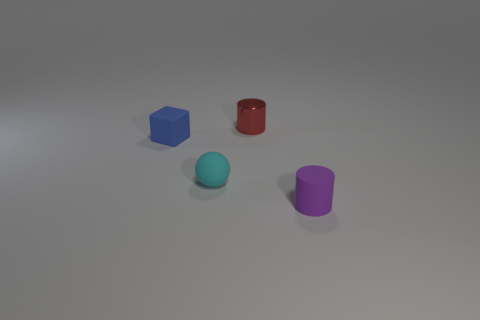Is there a pattern to the arrangement of the objects in the image? There doesn't appear to be a deliberate pattern, but the objects are spaced out relatively evenly across the surface, suggesting that they might have been positioned intentionally rather than randomly. Each object is isolated without overlapping or touching the others. 